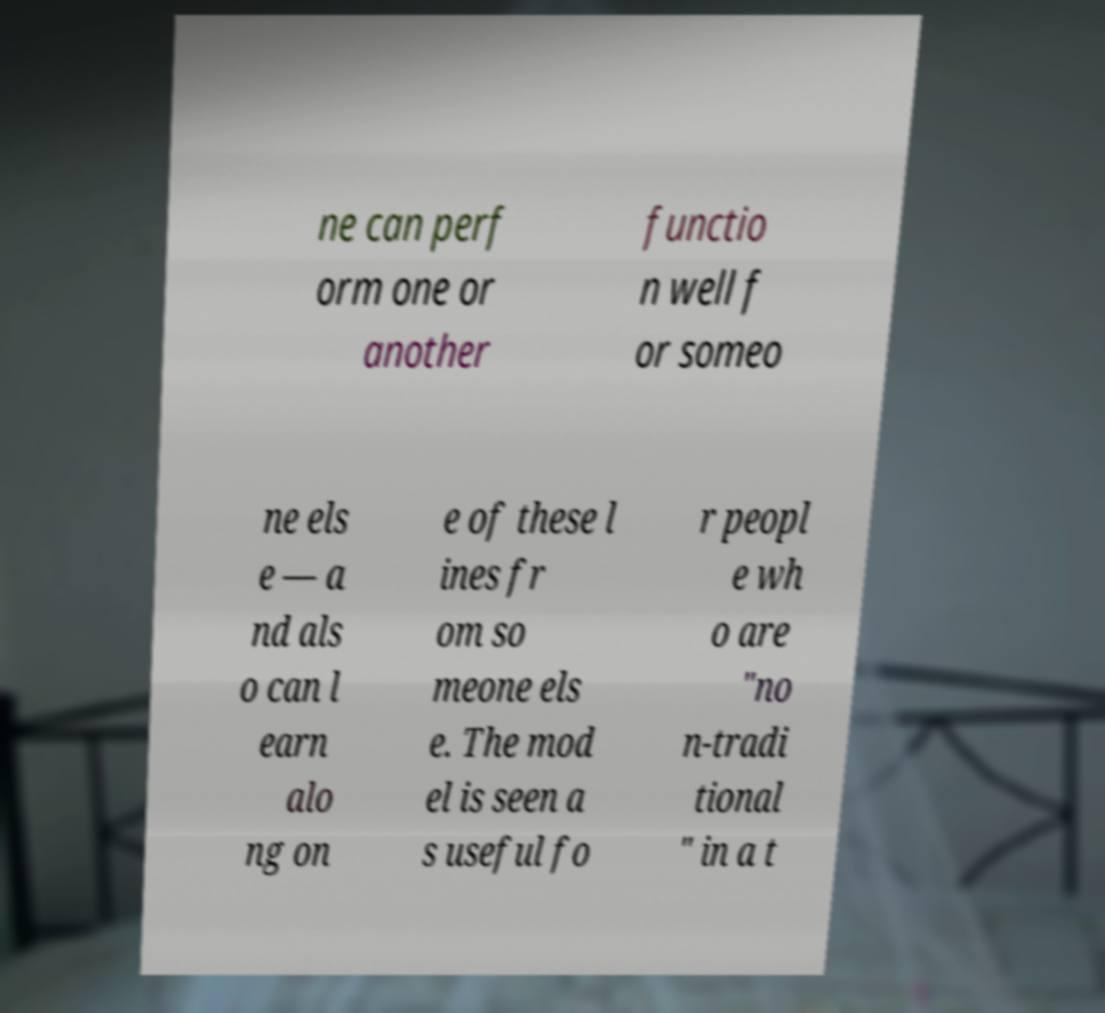Could you extract and type out the text from this image? ne can perf orm one or another functio n well f or someo ne els e — a nd als o can l earn alo ng on e of these l ines fr om so meone els e. The mod el is seen a s useful fo r peopl e wh o are "no n-tradi tional " in a t 